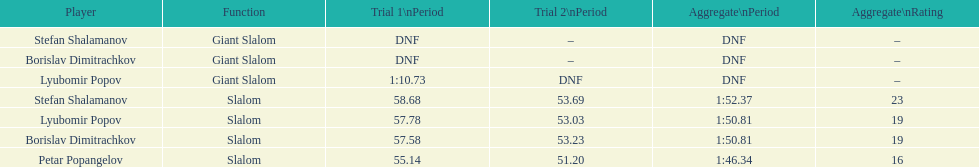How many athletes are there total? 4. 